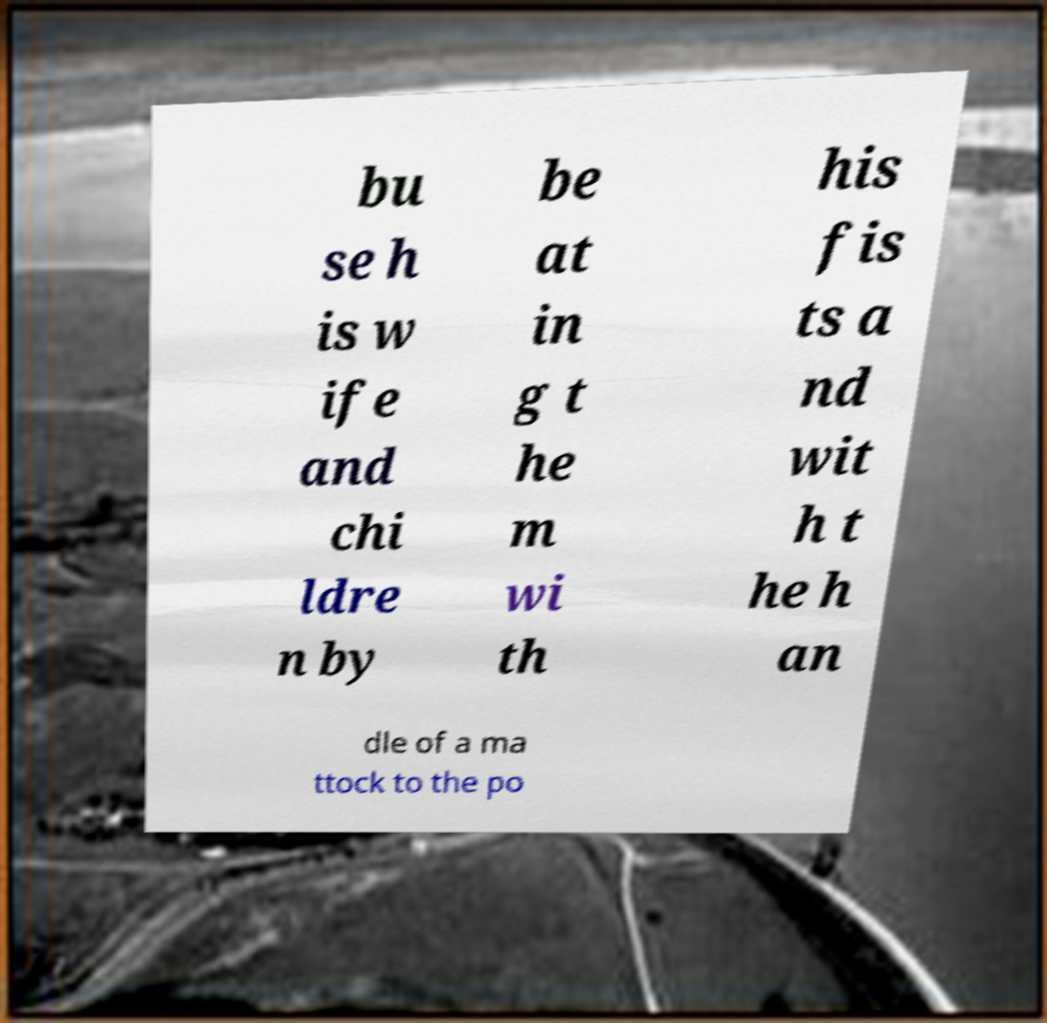I need the written content from this picture converted into text. Can you do that? bu se h is w ife and chi ldre n by be at in g t he m wi th his fis ts a nd wit h t he h an dle of a ma ttock to the po 